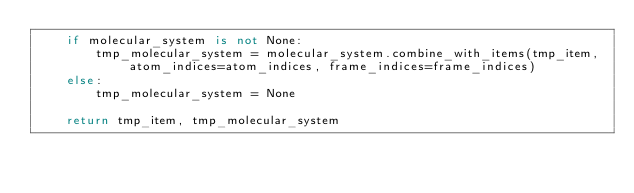<code> <loc_0><loc_0><loc_500><loc_500><_Python_>    if molecular_system is not None:
        tmp_molecular_system = molecular_system.combine_with_items(tmp_item, atom_indices=atom_indices, frame_indices=frame_indices)
    else:
        tmp_molecular_system = None

    return tmp_item, tmp_molecular_system

</code> 